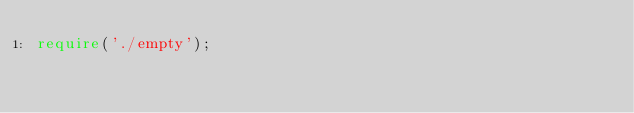Convert code to text. <code><loc_0><loc_0><loc_500><loc_500><_TypeScript_>require('./empty');</code> 